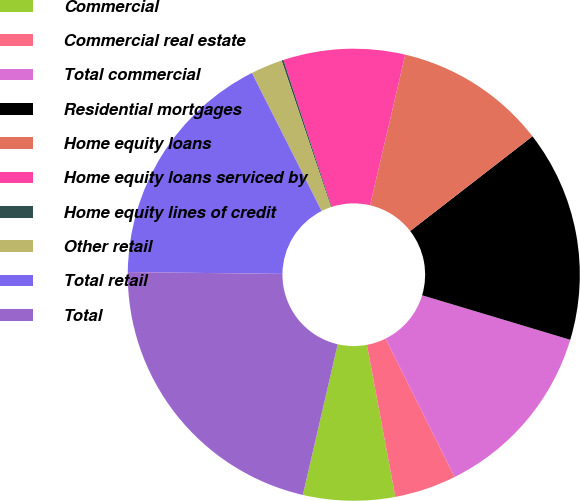Convert chart. <chart><loc_0><loc_0><loc_500><loc_500><pie_chart><fcel>Commercial<fcel>Commercial real estate<fcel>Total commercial<fcel>Residential mortgages<fcel>Home equity loans<fcel>Home equity loans serviced by<fcel>Home equity lines of credit<fcel>Other retail<fcel>Total retail<fcel>Total<nl><fcel>6.56%<fcel>4.42%<fcel>12.99%<fcel>15.14%<fcel>10.85%<fcel>8.7%<fcel>0.13%<fcel>2.27%<fcel>17.37%<fcel>21.57%<nl></chart> 